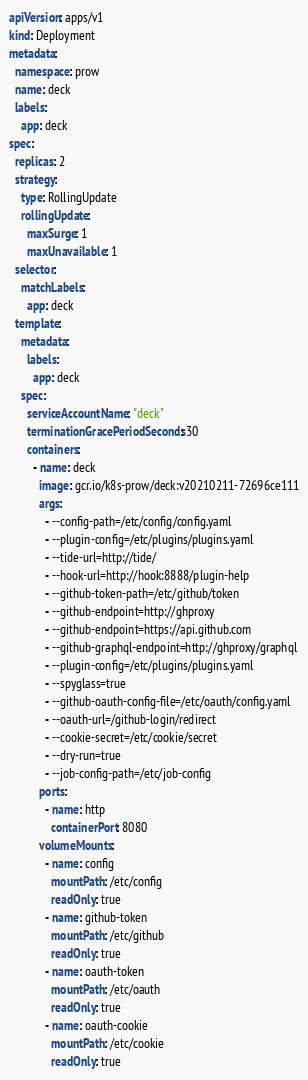Convert code to text. <code><loc_0><loc_0><loc_500><loc_500><_YAML_>apiVersion: apps/v1
kind: Deployment
metadata:
  namespace: prow
  name: deck
  labels:
    app: deck
spec:
  replicas: 2
  strategy:
    type: RollingUpdate
    rollingUpdate:
      maxSurge: 1
      maxUnavailable: 1
  selector:
    matchLabels:
      app: deck
  template:
    metadata:
      labels:
        app: deck
    spec:
      serviceAccountName: "deck"
      terminationGracePeriodSeconds: 30
      containers:
        - name: deck
          image: gcr.io/k8s-prow/deck:v20210211-72696ce111
          args:
            - --config-path=/etc/config/config.yaml
            - --plugin-config=/etc/plugins/plugins.yaml
            - --tide-url=http://tide/
            - --hook-url=http://hook:8888/plugin-help
            - --github-token-path=/etc/github/token
            - --github-endpoint=http://ghproxy
            - --github-endpoint=https://api.github.com
            - --github-graphql-endpoint=http://ghproxy/graphql
            - --plugin-config=/etc/plugins/plugins.yaml
            - --spyglass=true
            - --github-oauth-config-file=/etc/oauth/config.yaml
            - --oauth-url=/github-login/redirect
            - --cookie-secret=/etc/cookie/secret
            - --dry-run=true
            - --job-config-path=/etc/job-config
          ports:
            - name: http
              containerPort: 8080
          volumeMounts:
            - name: config
              mountPath: /etc/config
              readOnly: true
            - name: github-token
              mountPath: /etc/github
              readOnly: true
            - name: oauth-token
              mountPath: /etc/oauth
              readOnly: true
            - name: oauth-cookie
              mountPath: /etc/cookie
              readOnly: true</code> 